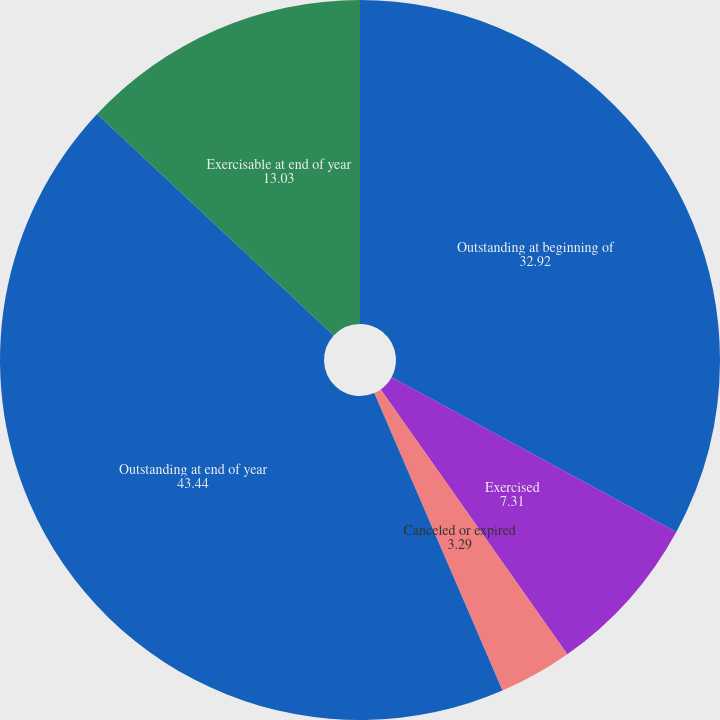Convert chart to OTSL. <chart><loc_0><loc_0><loc_500><loc_500><pie_chart><fcel>Outstanding at beginning of<fcel>Exercised<fcel>Canceled or expired<fcel>Outstanding at end of year<fcel>Exercisable at end of year<nl><fcel>32.92%<fcel>7.31%<fcel>3.29%<fcel>43.44%<fcel>13.03%<nl></chart> 